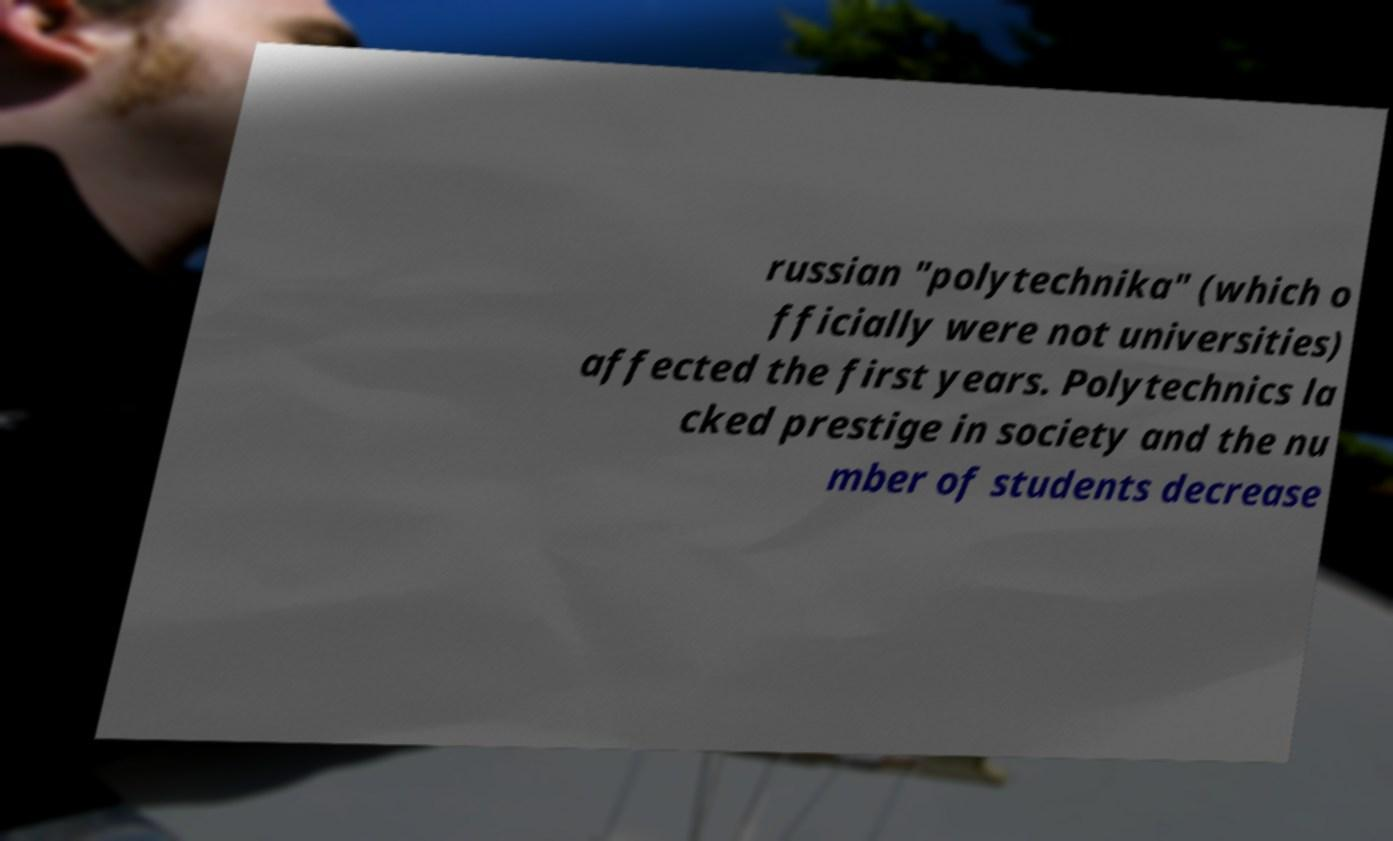Please identify and transcribe the text found in this image. russian "polytechnika" (which o fficially were not universities) affected the first years. Polytechnics la cked prestige in society and the nu mber of students decrease 